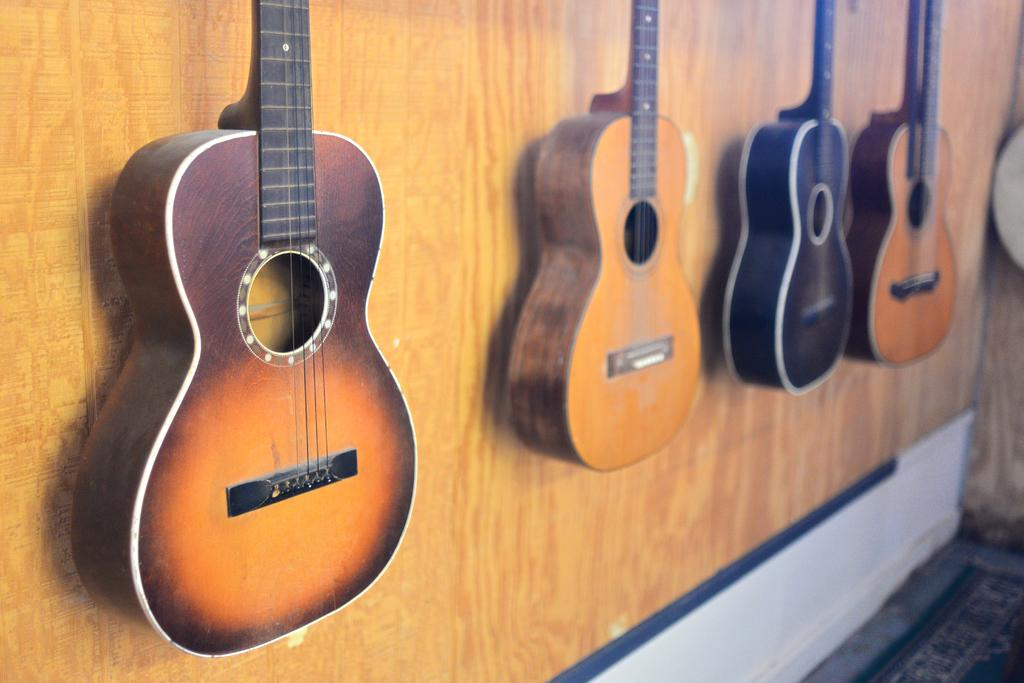How many guitars can be seen in the image? There are four guitars in the image. Where are the guitars located? The guitars are hanging on the wall. What is the arrangement of the guitars in the image? The guitars are located in the center of the image. What type of steel is used to make the guitars in the image? The image does not provide information about the type of steel used to make the guitars. 